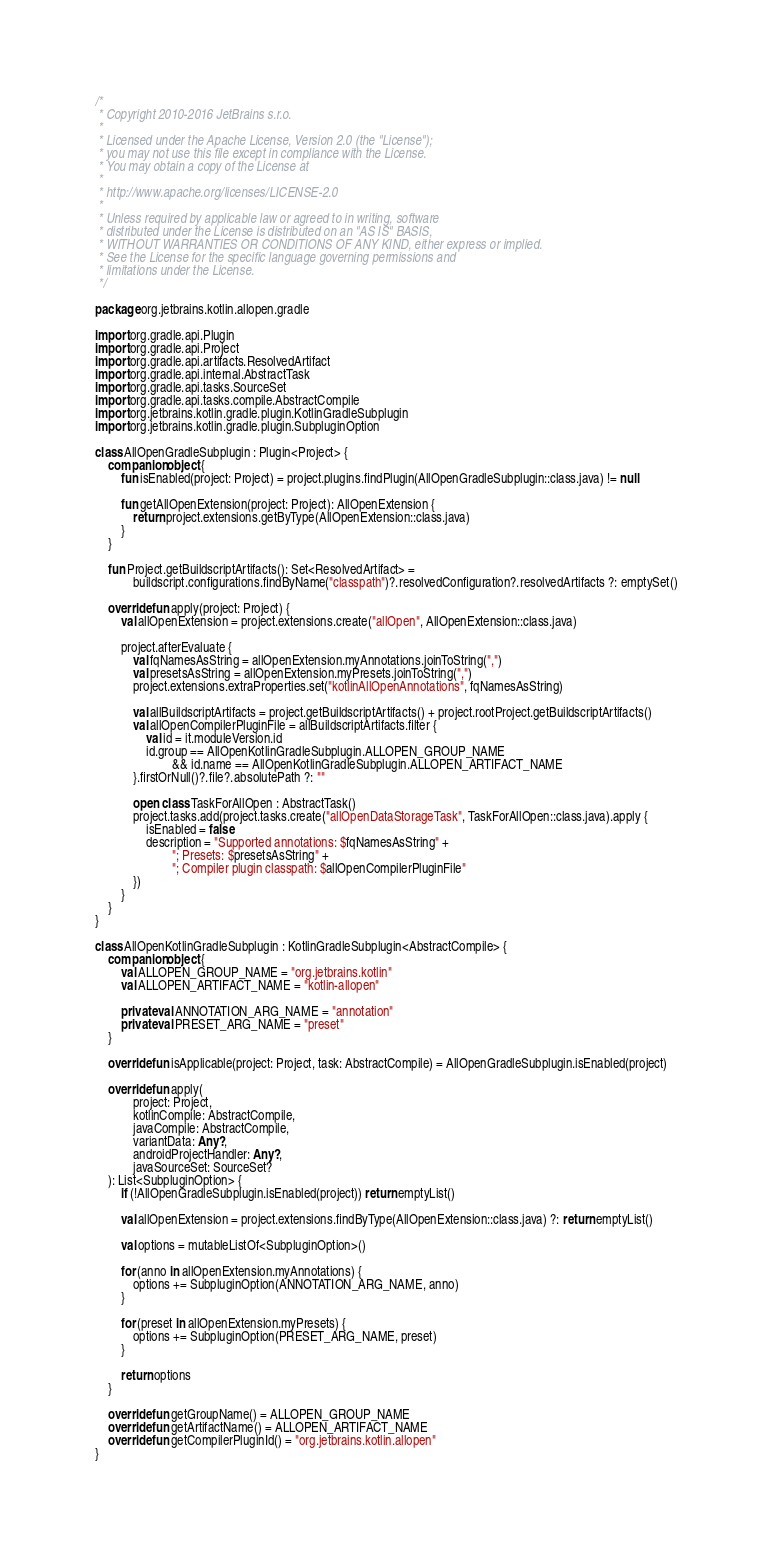<code> <loc_0><loc_0><loc_500><loc_500><_Kotlin_>/*
 * Copyright 2010-2016 JetBrains s.r.o.
 *
 * Licensed under the Apache License, Version 2.0 (the "License");
 * you may not use this file except in compliance with the License.
 * You may obtain a copy of the License at
 *
 * http://www.apache.org/licenses/LICENSE-2.0
 *
 * Unless required by applicable law or agreed to in writing, software
 * distributed under the License is distributed on an "AS IS" BASIS,
 * WITHOUT WARRANTIES OR CONDITIONS OF ANY KIND, either express or implied.
 * See the License for the specific language governing permissions and
 * limitations under the License.
 */

package org.jetbrains.kotlin.allopen.gradle

import org.gradle.api.Plugin
import org.gradle.api.Project
import org.gradle.api.artifacts.ResolvedArtifact
import org.gradle.api.internal.AbstractTask
import org.gradle.api.tasks.SourceSet
import org.gradle.api.tasks.compile.AbstractCompile
import org.jetbrains.kotlin.gradle.plugin.KotlinGradleSubplugin
import org.jetbrains.kotlin.gradle.plugin.SubpluginOption

class AllOpenGradleSubplugin : Plugin<Project> {
    companion object {
        fun isEnabled(project: Project) = project.plugins.findPlugin(AllOpenGradleSubplugin::class.java) != null

        fun getAllOpenExtension(project: Project): AllOpenExtension {
            return project.extensions.getByType(AllOpenExtension::class.java)
        }
    }

    fun Project.getBuildscriptArtifacts(): Set<ResolvedArtifact> =
            buildscript.configurations.findByName("classpath")?.resolvedConfiguration?.resolvedArtifacts ?: emptySet()

    override fun apply(project: Project) {
        val allOpenExtension = project.extensions.create("allOpen", AllOpenExtension::class.java)

        project.afterEvaluate {
            val fqNamesAsString = allOpenExtension.myAnnotations.joinToString(",")
            val presetsAsString = allOpenExtension.myPresets.joinToString(",")
            project.extensions.extraProperties.set("kotlinAllOpenAnnotations", fqNamesAsString)

            val allBuildscriptArtifacts = project.getBuildscriptArtifacts() + project.rootProject.getBuildscriptArtifacts()
            val allOpenCompilerPluginFile = allBuildscriptArtifacts.filter {
                val id = it.moduleVersion.id
                id.group == AllOpenKotlinGradleSubplugin.ALLOPEN_GROUP_NAME
                        && id.name == AllOpenKotlinGradleSubplugin.ALLOPEN_ARTIFACT_NAME
            }.firstOrNull()?.file?.absolutePath ?: ""

            open class TaskForAllOpen : AbstractTask()
            project.tasks.add(project.tasks.create("allOpenDataStorageTask", TaskForAllOpen::class.java).apply {
                isEnabled = false
                description = "Supported annotations: $fqNamesAsString" +
                        "; Presets: $presetsAsString" +
                        "; Compiler plugin classpath: $allOpenCompilerPluginFile"
            })
        }
    }
}

class AllOpenKotlinGradleSubplugin : KotlinGradleSubplugin<AbstractCompile> {
    companion object {
        val ALLOPEN_GROUP_NAME = "org.jetbrains.kotlin"
        val ALLOPEN_ARTIFACT_NAME = "kotlin-allopen"

        private val ANNOTATION_ARG_NAME = "annotation"
        private val PRESET_ARG_NAME = "preset"
    }

    override fun isApplicable(project: Project, task: AbstractCompile) = AllOpenGradleSubplugin.isEnabled(project)

    override fun apply(
            project: Project,
            kotlinCompile: AbstractCompile,
            javaCompile: AbstractCompile,
            variantData: Any?,
            androidProjectHandler: Any?,
            javaSourceSet: SourceSet?
    ): List<SubpluginOption> {
        if (!AllOpenGradleSubplugin.isEnabled(project)) return emptyList()

        val allOpenExtension = project.extensions.findByType(AllOpenExtension::class.java) ?: return emptyList()

        val options = mutableListOf<SubpluginOption>()

        for (anno in allOpenExtension.myAnnotations) {
            options += SubpluginOption(ANNOTATION_ARG_NAME, anno)
        }

        for (preset in allOpenExtension.myPresets) {
            options += SubpluginOption(PRESET_ARG_NAME, preset)
        }

        return options
    }

    override fun getGroupName() = ALLOPEN_GROUP_NAME
    override fun getArtifactName() = ALLOPEN_ARTIFACT_NAME
    override fun getCompilerPluginId() = "org.jetbrains.kotlin.allopen"
}</code> 